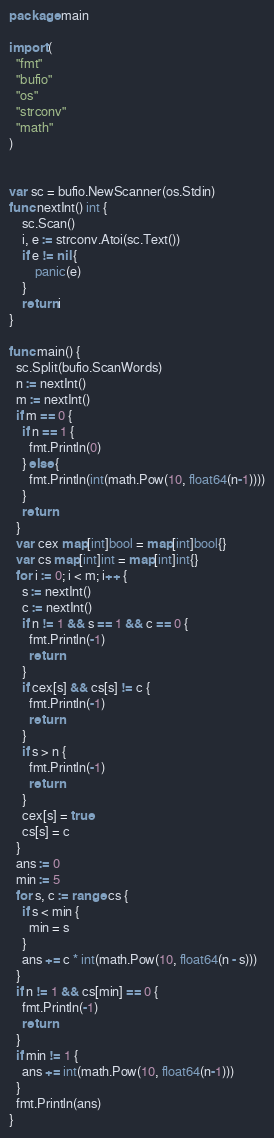Convert code to text. <code><loc_0><loc_0><loc_500><loc_500><_Go_>package main

import (
  "fmt"
  "bufio"
  "os"
  "strconv"
  "math"
)


var sc = bufio.NewScanner(os.Stdin)
func nextInt() int {
    sc.Scan()
    i, e := strconv.Atoi(sc.Text())
    if e != nil {
        panic(e)
    }
    return i
}

func main() {
  sc.Split(bufio.ScanWords)
  n := nextInt()
  m := nextInt()
  if m == 0 {
    if n == 1 {
      fmt.Println(0)
    } else {
      fmt.Println(int(math.Pow(10, float64(n-1))))
    }
    return
  }
  var cex map[int]bool = map[int]bool{}
  var cs map[int]int = map[int]int{}
  for i := 0; i < m; i++ {
    s := nextInt()
    c := nextInt()
    if n != 1 && s == 1 && c == 0 {
      fmt.Println(-1)
      return
    }
    if cex[s] && cs[s] != c {
      fmt.Println(-1)
      return
    }
    if s > n {
      fmt.Println(-1)
      return
    }
    cex[s] = true
    cs[s] = c
  }
  ans := 0
  min := 5
  for s, c := range cs {
    if s < min {
      min = s
    }
    ans += c * int(math.Pow(10, float64(n - s)))
  }
  if n != 1 && cs[min] == 0 {
    fmt.Println(-1)
    return
  }
  if min != 1 {
    ans += int(math.Pow(10, float64(n-1)))
  }
  fmt.Println(ans)
}
</code> 